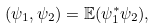<formula> <loc_0><loc_0><loc_500><loc_500>( \psi _ { 1 } , \psi _ { 2 } ) = \mathbb { E } ( \psi _ { 1 } ^ { * } \psi _ { 2 } ) ,</formula> 